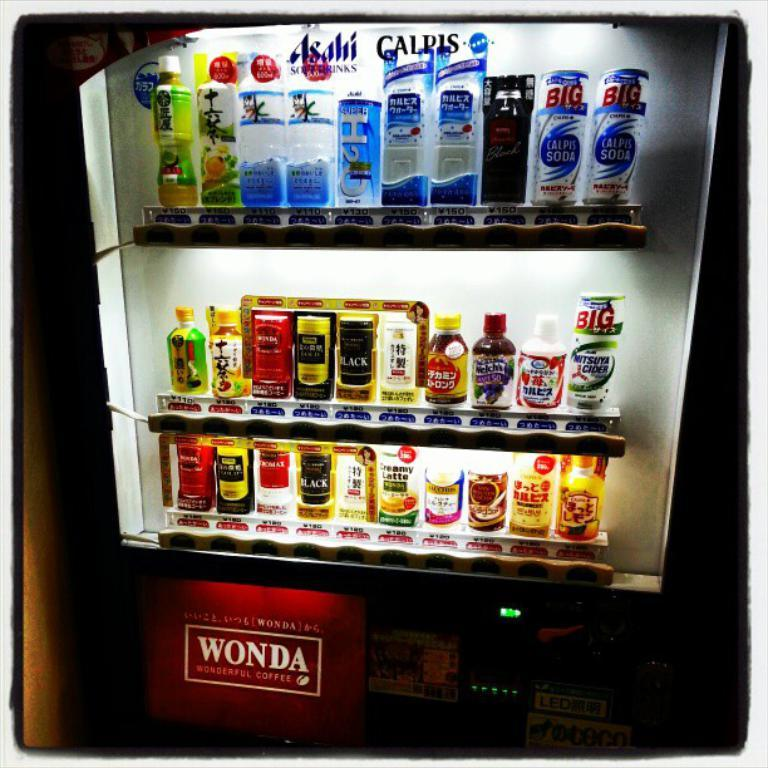<image>
Give a short and clear explanation of the subsequent image. a drink vending machine with the word 'Wonda' at the bottom 